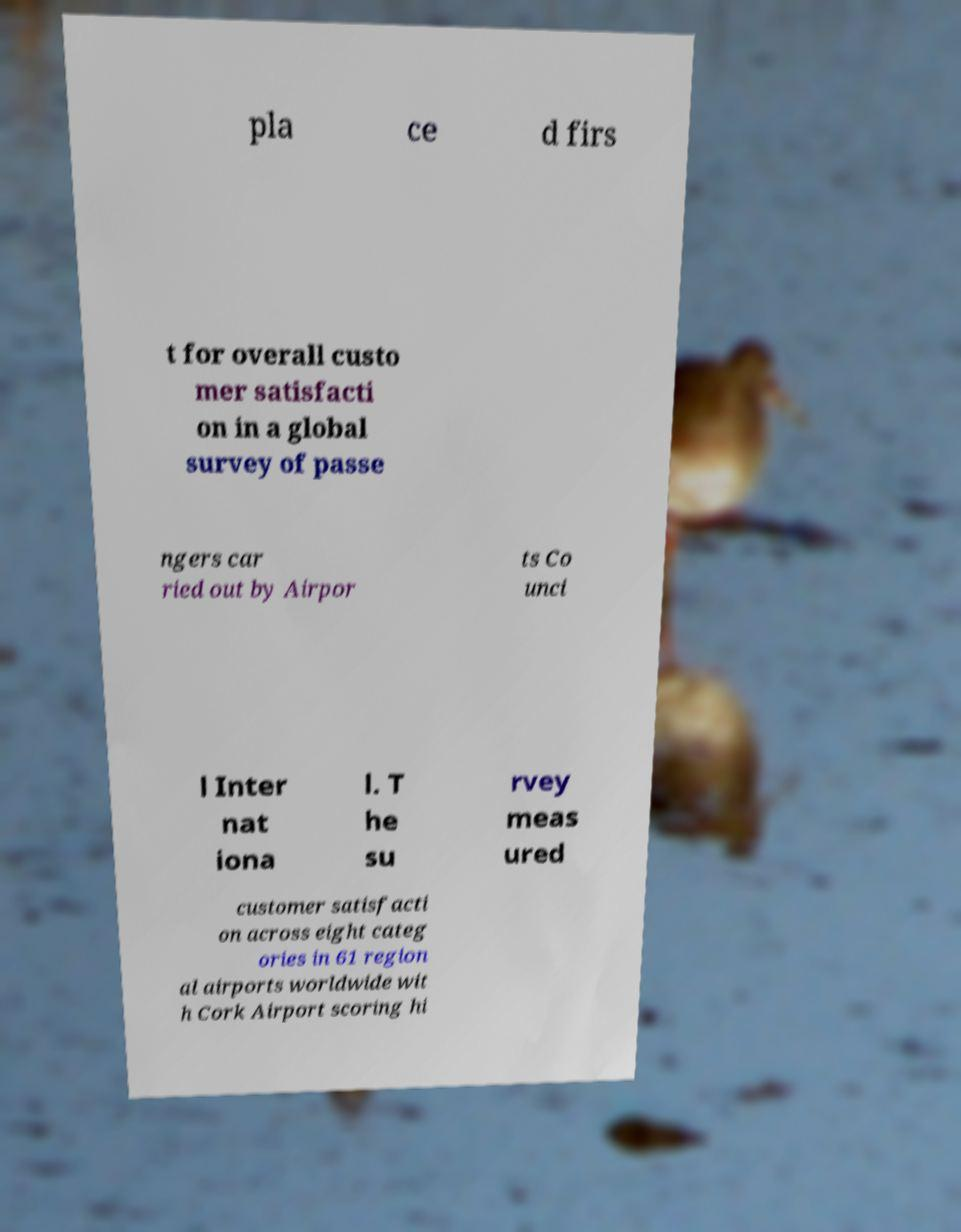Please read and relay the text visible in this image. What does it say? pla ce d firs t for overall custo mer satisfacti on in a global survey of passe ngers car ried out by Airpor ts Co unci l Inter nat iona l. T he su rvey meas ured customer satisfacti on across eight categ ories in 61 region al airports worldwide wit h Cork Airport scoring hi 